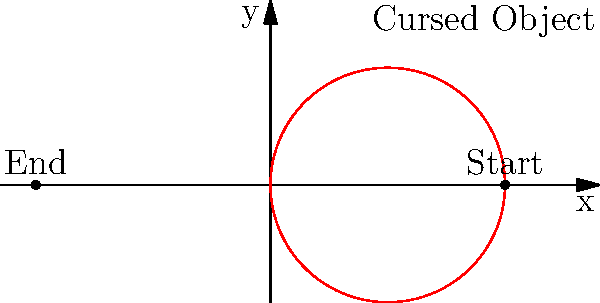In a spine-chilling scene from a horror movie, a cursed doll is thrown in a curved path. The trajectory of the doll can be described by the polar equation $r = 5\cos(\theta)$, where $r$ is measured in meters. What is the maximum height reached by the cursed doll during its eerie flight? To find the maximum height of the cursed doll's trajectory, we need to follow these haunting steps:

1) The polar equation $r = 5\cos(\theta)$ describes a circle with diameter 5 meters along the x-axis.

2) The center of this circle is at (2.5, 0) in Cartesian coordinates.

3) The maximum height will occur at the top of the circle, which is 2.5 meters above the center.

4) To calculate this:
   Maximum height = Radius of the circle
   Radius = Diameter / 2 = 5 / 2 = 2.5 meters

5) Therefore, the maximum height reached by the cursed doll is 2.5 meters above the x-axis.

This unsettling path ensures the doll reaches its zenith at exactly half its starting distance from the origin, creating a perfectly symmetrical arc of terror.
Answer: 2.5 meters 